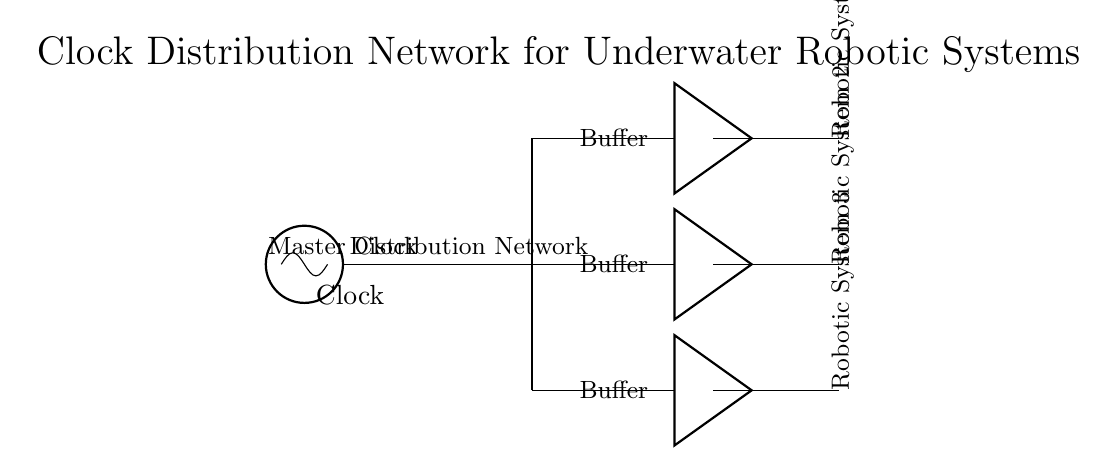What is the function of the component labeled "Clock"? The component labeled "Clock" acts as the master clock source that generates a timing signal to synchronize the operation of multiple robotic systems.
Answer: Clock How many robotic systems are connected to the buffer outputs? There are three robotic systems connected to the buffer outputs, as indicated by the lines leading from the buffers to each robotic system.
Answer: Three What is the purpose of the buffers in this circuit? Buffers are used in this circuit to strengthen the signal from the clock and ensure that it can be effectively distributed to the robotic systems without degradation.
Answer: Strengthening signal Which component directly connects to the master clock? The distribution network directly connects to the master clock, taking the clock signal to the various buffers that then connect to the robotic systems.
Answer: Distribution network What is the orientation of the labels for the robotic systems? The labels for the robotic systems are placed in a vertical orientation, as evident from their 90-degree rotation on the diagram.
Answer: Vertical What is the primary function of the distribution network in this circuit? The distribution network serves to spread the clock signal from the master clock to each of the buffers, ensuring they all receive the timing signal mapped for synchronization.
Answer: Spread clock signal 